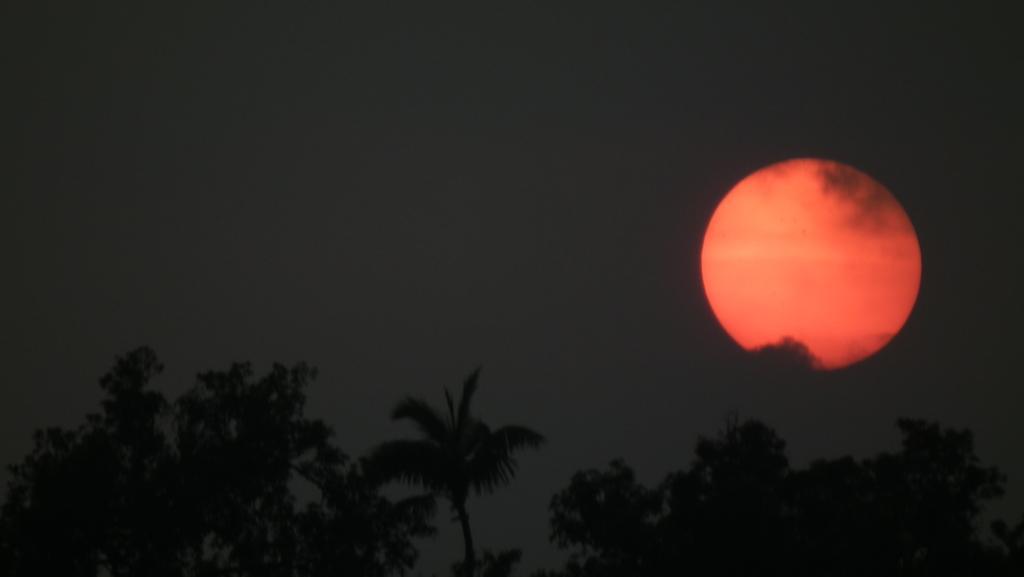In one or two sentences, can you explain what this image depicts? In this image, we can see so many trees, moon and sky. 